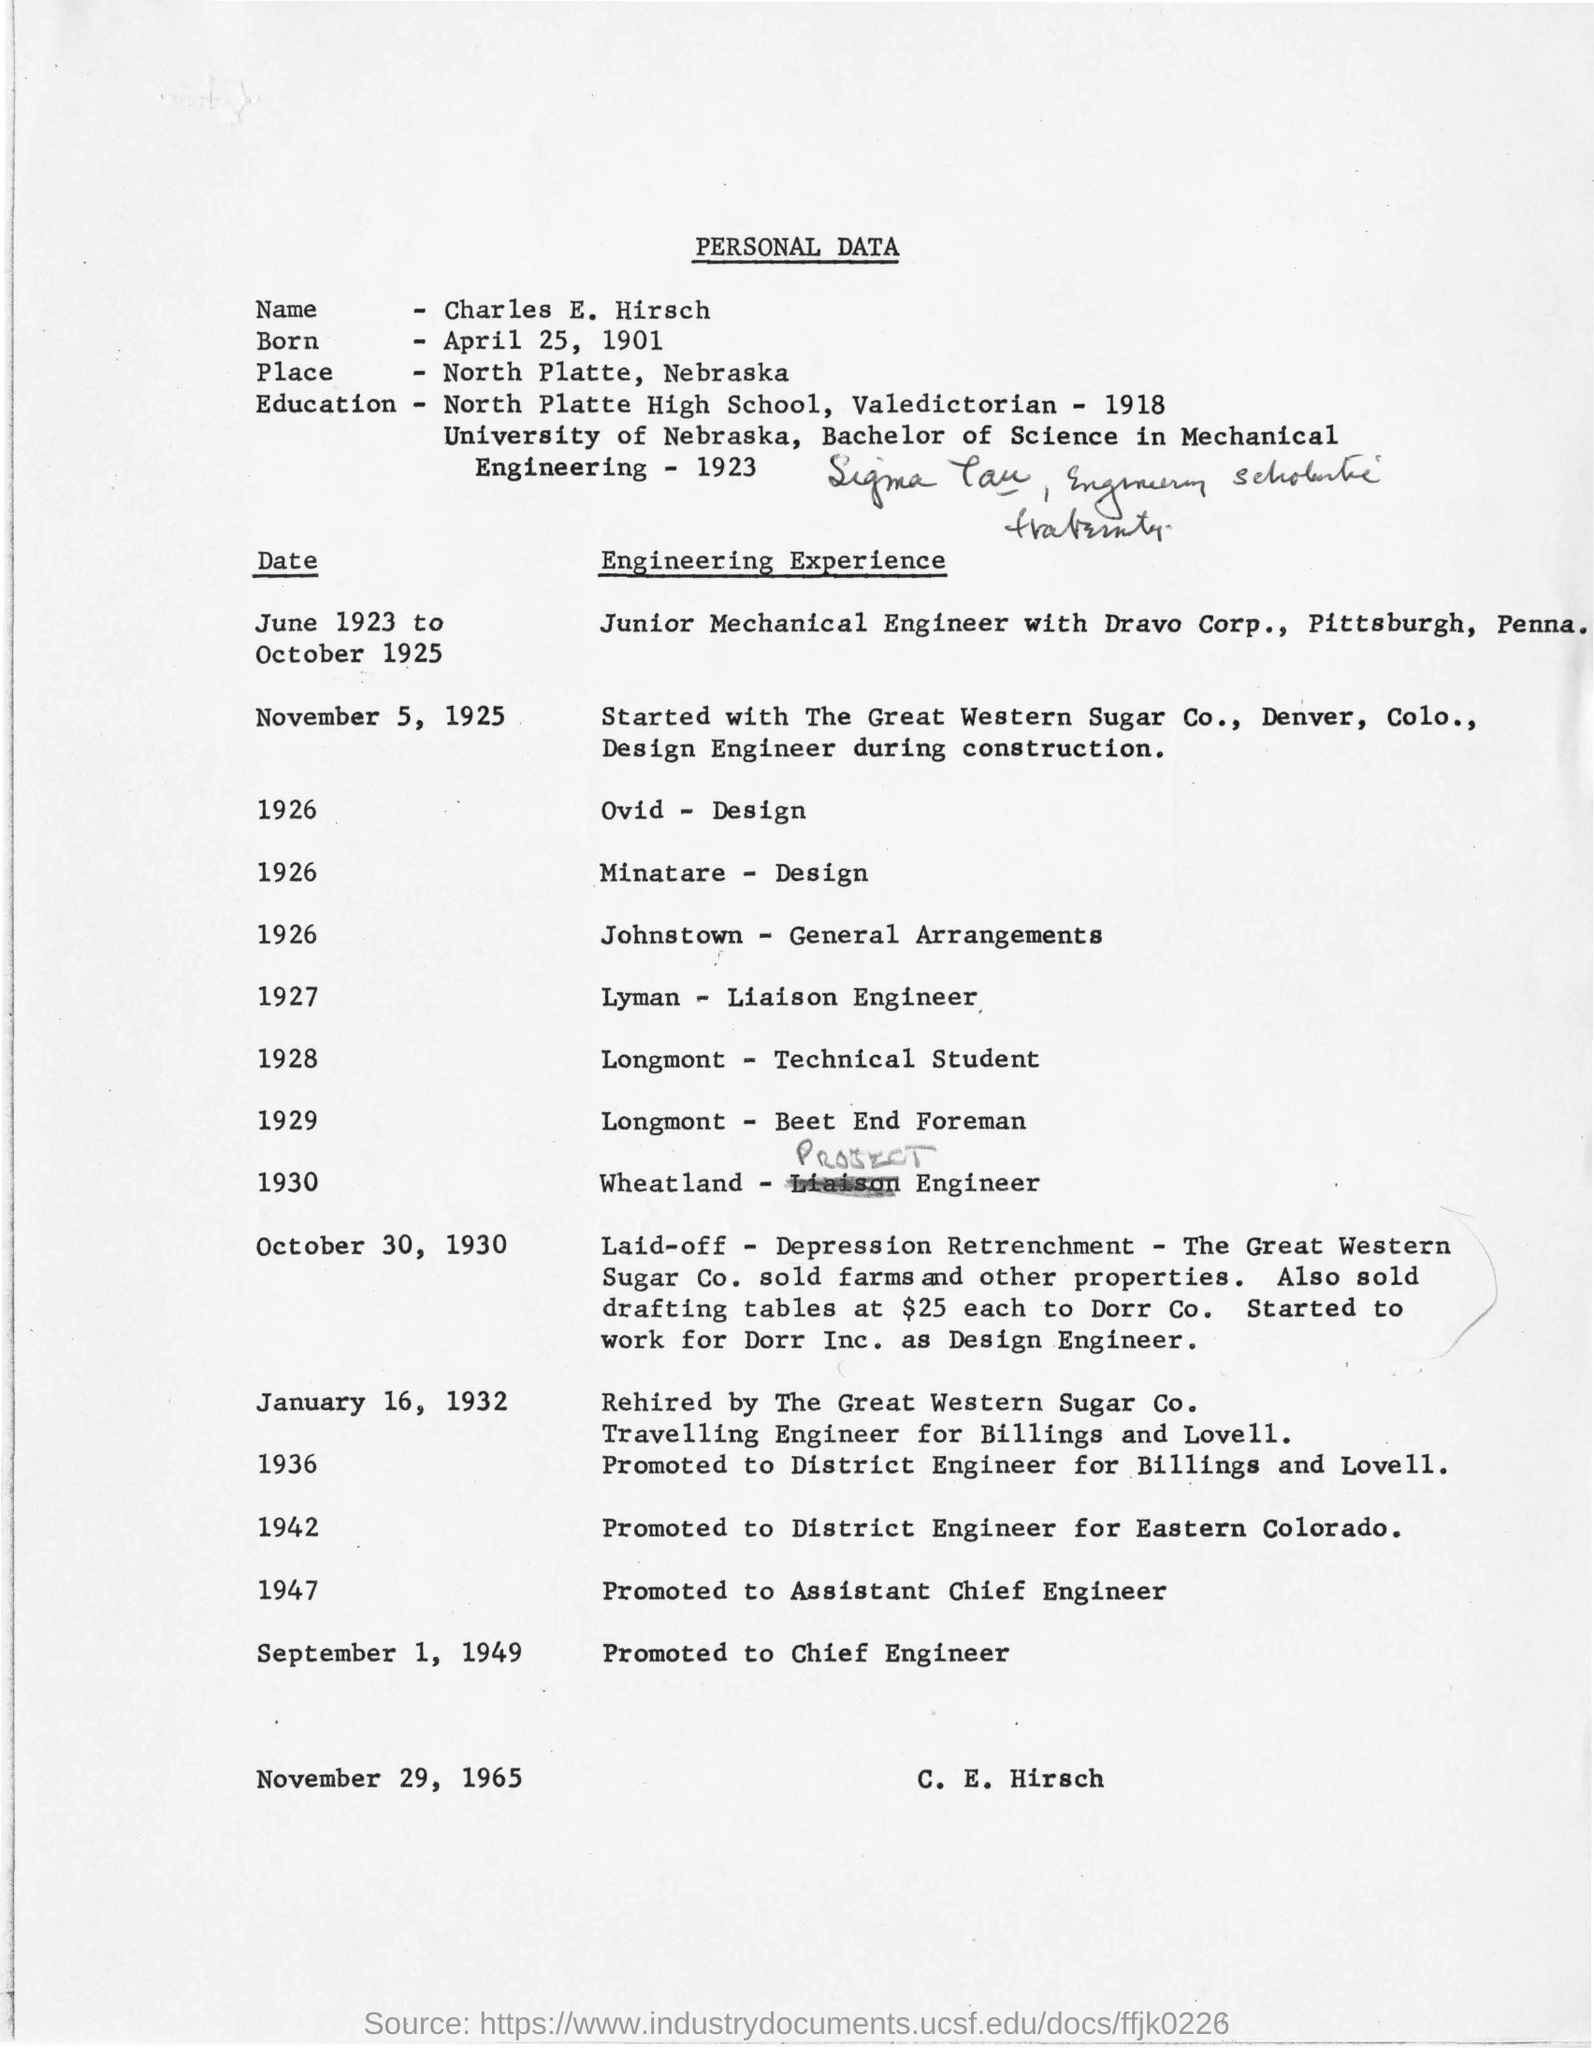Whose personal data is given here?
Provide a succinct answer. C. E. Hirsch. What is the date of birth of Charles E. Hirsch?
Provide a succinct answer. April 25, 1901. When did Charles E. Hirsch promoted as Chief Engineer?
Your answer should be very brief. September 1, 1949. 